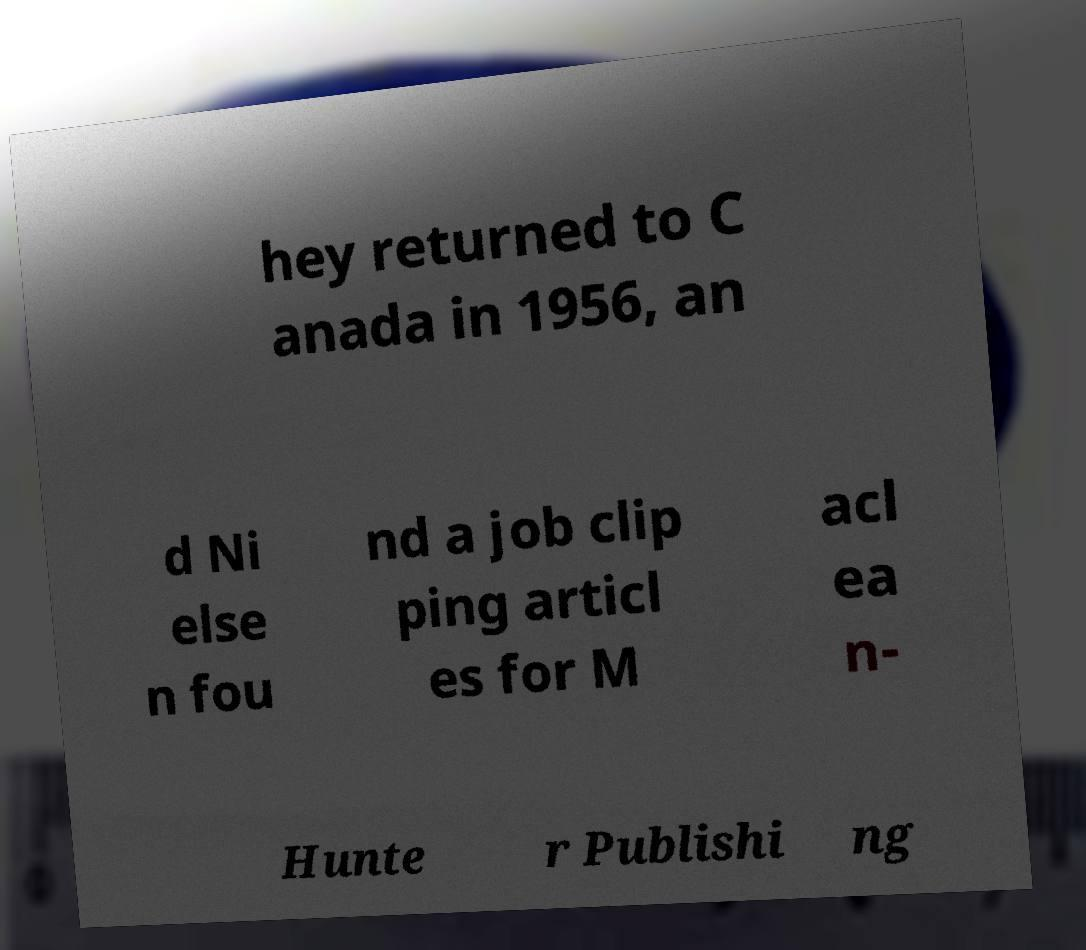What messages or text are displayed in this image? I need them in a readable, typed format. hey returned to C anada in 1956, an d Ni else n fou nd a job clip ping articl es for M acl ea n- Hunte r Publishi ng 